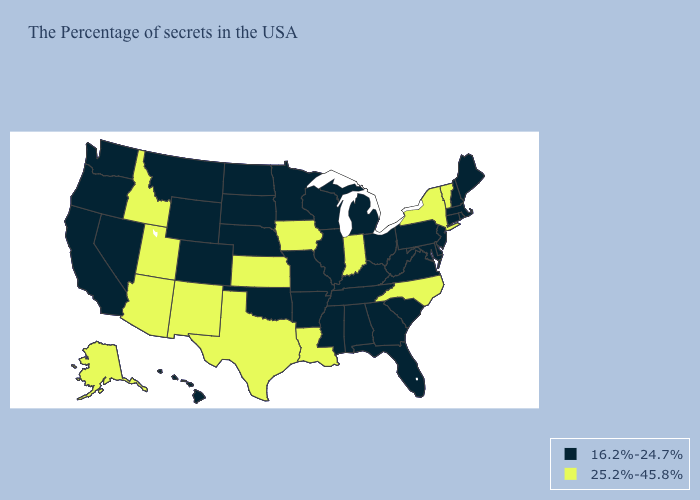What is the value of Ohio?
Short answer required. 16.2%-24.7%. Among the states that border Louisiana , does Texas have the highest value?
Be succinct. Yes. Does North Carolina have the lowest value in the USA?
Concise answer only. No. What is the highest value in the USA?
Write a very short answer. 25.2%-45.8%. What is the value of Virginia?
Keep it brief. 16.2%-24.7%. Among the states that border Massachusetts , which have the highest value?
Give a very brief answer. Vermont, New York. What is the value of Alabama?
Keep it brief. 16.2%-24.7%. Among the states that border Vermont , does Massachusetts have the highest value?
Answer briefly. No. Among the states that border Indiana , which have the lowest value?
Short answer required. Ohio, Michigan, Kentucky, Illinois. Name the states that have a value in the range 25.2%-45.8%?
Keep it brief. Vermont, New York, North Carolina, Indiana, Louisiana, Iowa, Kansas, Texas, New Mexico, Utah, Arizona, Idaho, Alaska. Name the states that have a value in the range 25.2%-45.8%?
Concise answer only. Vermont, New York, North Carolina, Indiana, Louisiana, Iowa, Kansas, Texas, New Mexico, Utah, Arizona, Idaho, Alaska. Among the states that border South Carolina , which have the highest value?
Quick response, please. North Carolina. What is the highest value in the USA?
Concise answer only. 25.2%-45.8%. Which states have the highest value in the USA?
Concise answer only. Vermont, New York, North Carolina, Indiana, Louisiana, Iowa, Kansas, Texas, New Mexico, Utah, Arizona, Idaho, Alaska. Is the legend a continuous bar?
Short answer required. No. 